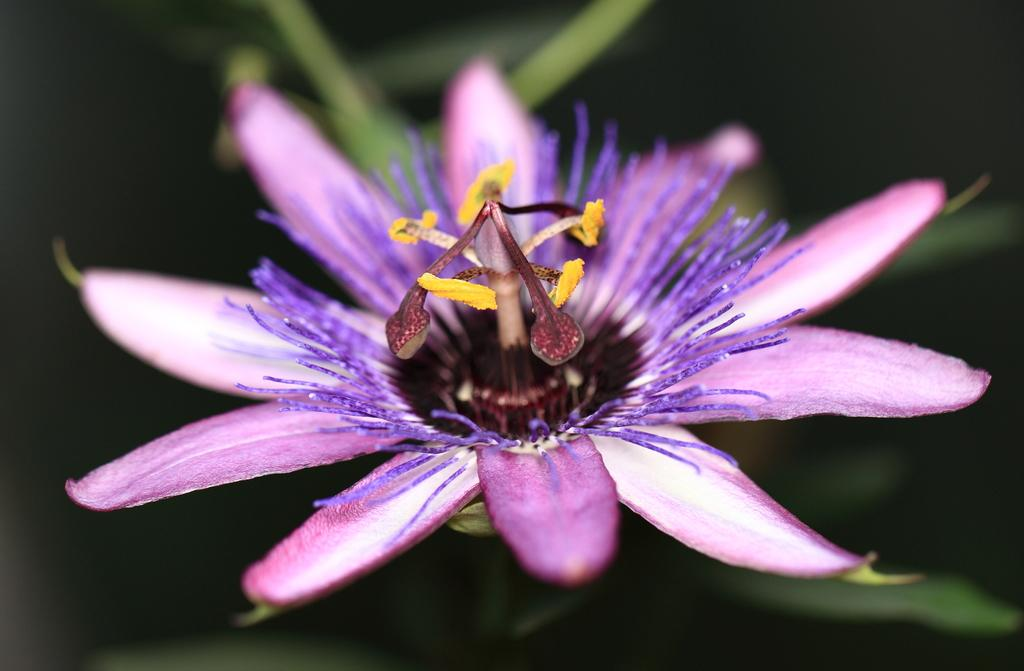What is the main subject of the image? There is a flower in the image. Can you describe the background of the image? The background of the image is blurred. How many pizzas are being shared by the couple in the image? There is no couple or pizzas present in the image; it features a flower with a blurred background. 